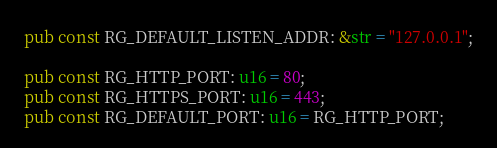Convert code to text. <code><loc_0><loc_0><loc_500><loc_500><_Rust_>pub const RG_DEFAULT_LISTEN_ADDR: &str = "127.0.0.1";

pub const RG_HTTP_PORT: u16 = 80;
pub const RG_HTTPS_PORT: u16 = 443;
pub const RG_DEFAULT_PORT: u16 = RG_HTTP_PORT;
</code> 